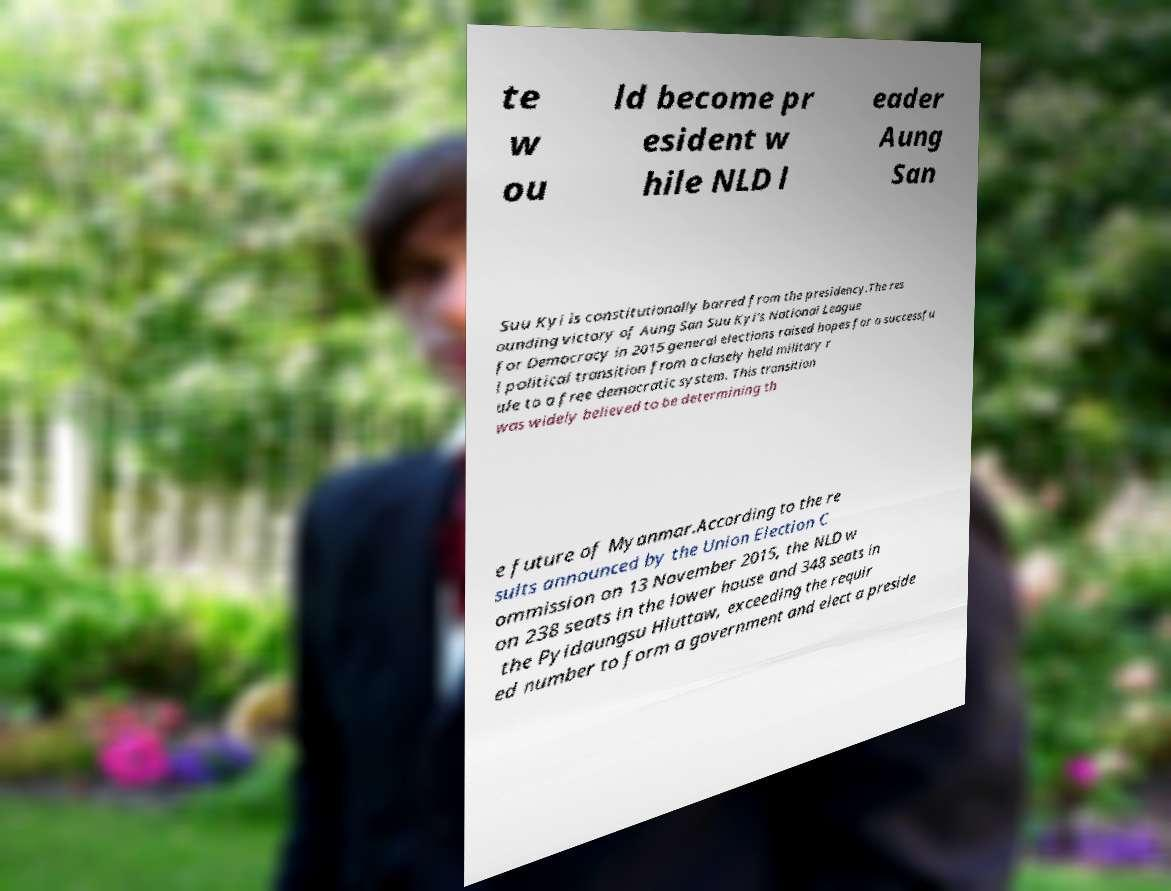Please read and relay the text visible in this image. What does it say? te w ou ld become pr esident w hile NLD l eader Aung San Suu Kyi is constitutionally barred from the presidency.The res ounding victory of Aung San Suu Kyi's National League for Democracy in 2015 general elections raised hopes for a successfu l political transition from a closely held military r ule to a free democratic system. This transition was widely believed to be determining th e future of Myanmar.According to the re sults announced by the Union Election C ommission on 13 November 2015, the NLD w on 238 seats in the lower house and 348 seats in the Pyidaungsu Hluttaw, exceeding the requir ed number to form a government and elect a preside 